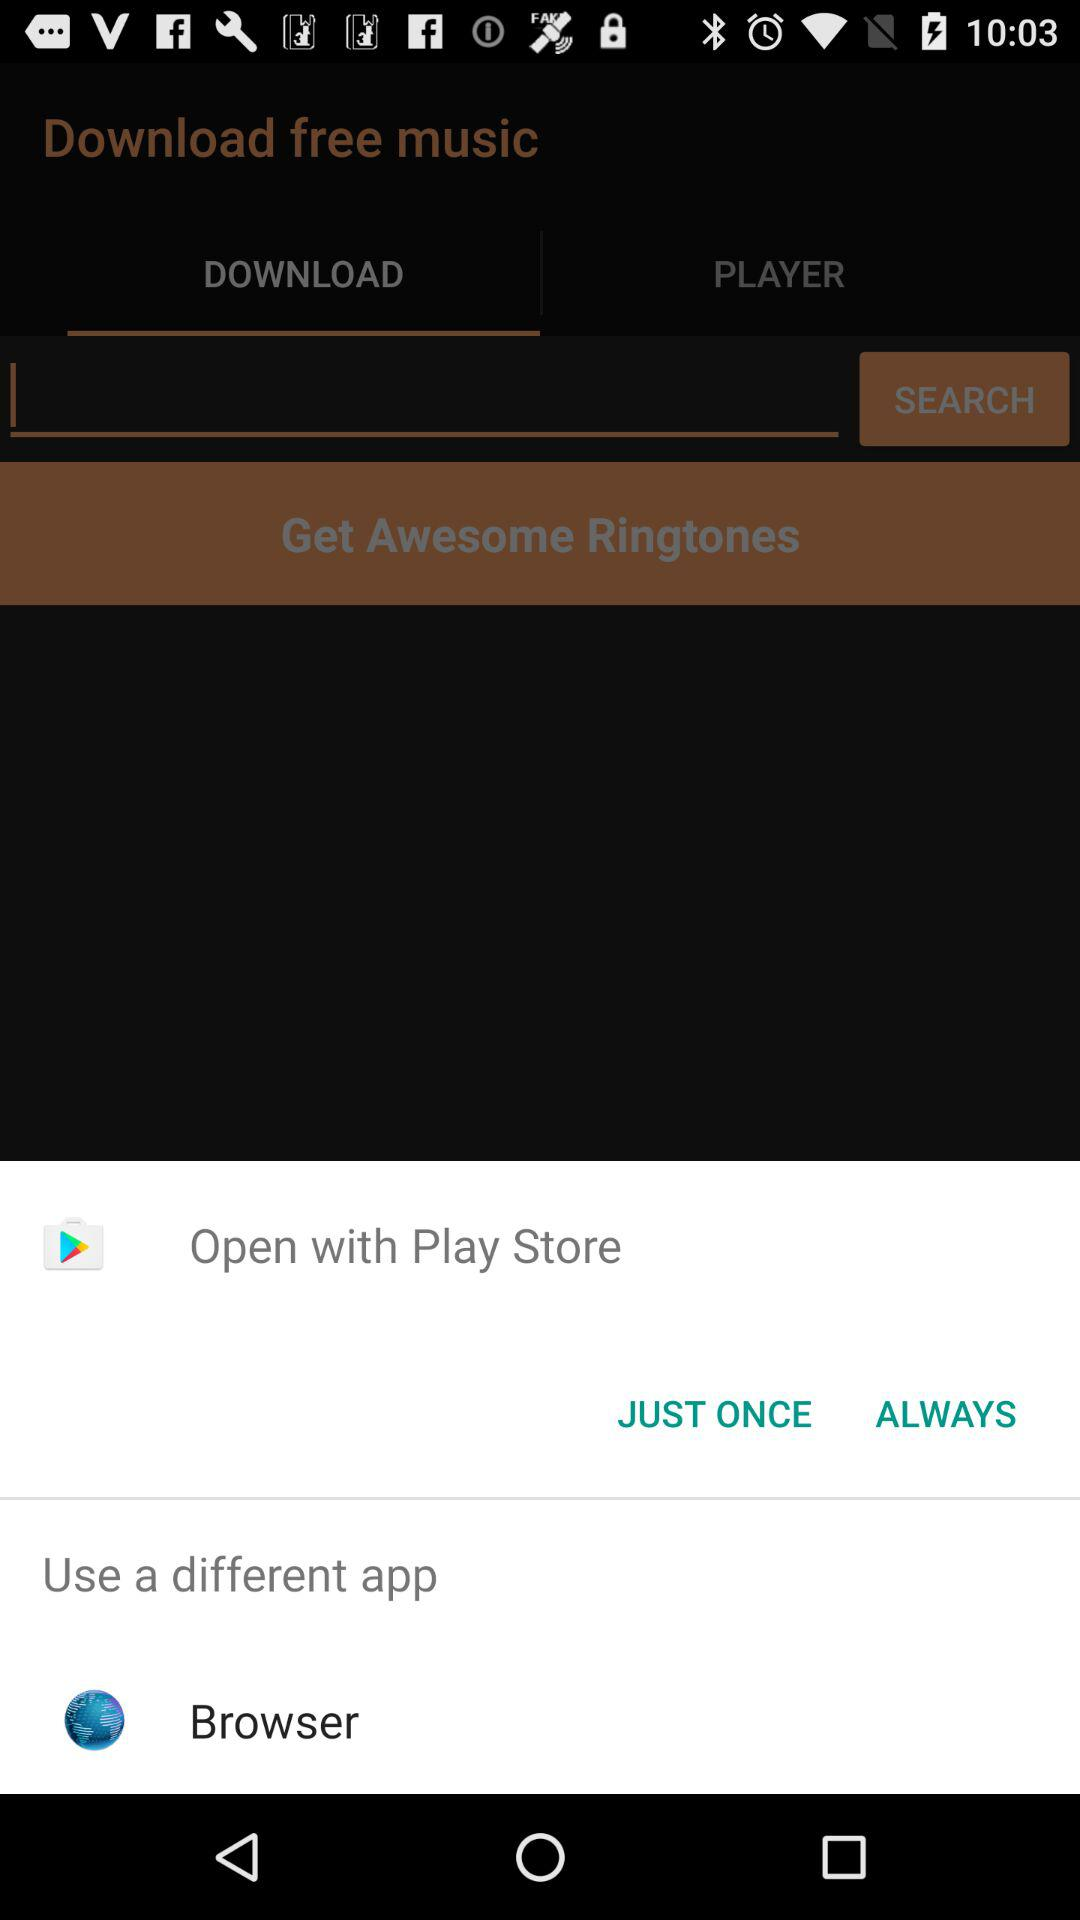What applications can be used to open this? The applications that can be used to open are "Play Store" and "Browser". 